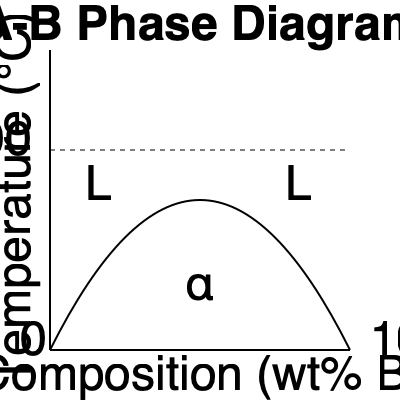In the given A-B binary phase diagram, at 600°C and 60 wt% B, what phases are present and what is the composition of the liquid phase? To analyze the phase diagram and answer the question, let's follow these steps:

1. Locate the point on the diagram:
   - Temperature: 600°C (horizontal line)
   - Composition: 60 wt% B (vertical line from bottom axis)

2. Identify the region:
   The point falls in the liquid (L) region of the phase diagram.

3. Determine the phases present:
   Since the point is in the liquid region, only the liquid phase is present.

4. Composition of the liquid phase:
   The composition of the liquid phase is the same as the overall composition, which is 60 wt% B.

5. Verify the single-phase region:
   The point is above the liquidus curve, confirming that only the liquid phase exists at this temperature and composition.

Therefore, at 600°C and 60 wt% B, the system consists of a single liquid phase with a composition of 60 wt% B.
Answer: Single liquid phase, 60 wt% B 